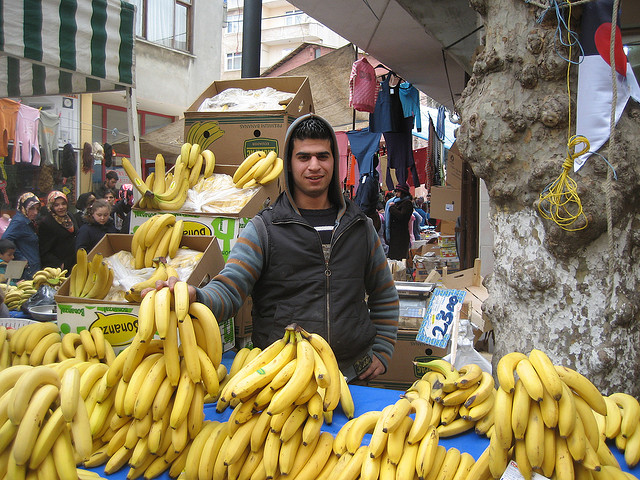Are there any notable details about the bananas or their arrangement? The bananas are neatly arranged to attract customers, with some still in boxes and others stacked on the table. This presentation suggests the vendor takes care in displaying the product to encourage sales. Is there anything else going on in the image that might provide context about the market? Behind the vendor, there are other market stalls and shoppers, indicating a bustling market atmosphere. Additionally, various items of clothing are being sold in the background, which hints at a diverse marketplace offering more than just produce. 